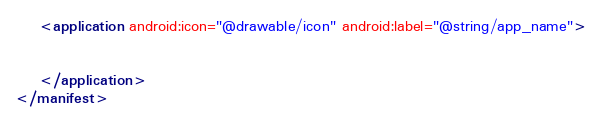<code> <loc_0><loc_0><loc_500><loc_500><_XML_>    <application android:icon="@drawable/icon" android:label="@string/app_name">


    </application>
</manifest></code> 